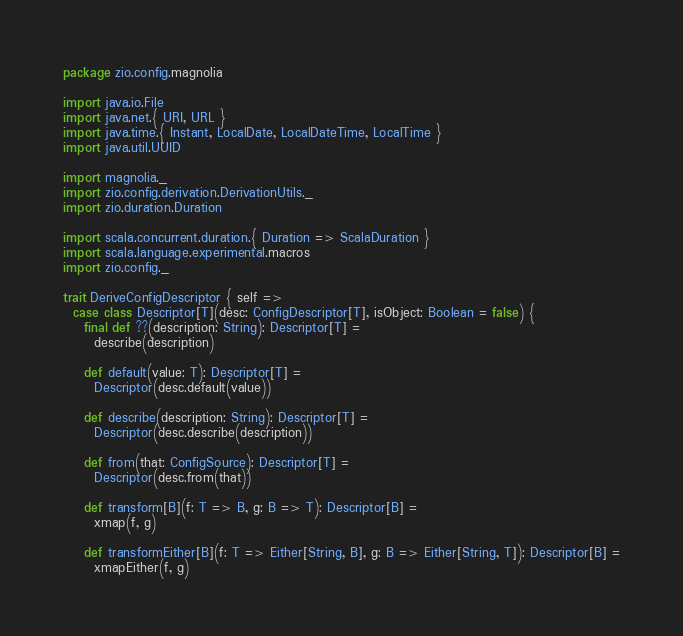Convert code to text. <code><loc_0><loc_0><loc_500><loc_500><_Scala_>package zio.config.magnolia

import java.io.File
import java.net.{ URI, URL }
import java.time.{ Instant, LocalDate, LocalDateTime, LocalTime }
import java.util.UUID

import magnolia._
import zio.config.derivation.DerivationUtils._
import zio.duration.Duration

import scala.concurrent.duration.{ Duration => ScalaDuration }
import scala.language.experimental.macros
import zio.config._

trait DeriveConfigDescriptor { self =>
  case class Descriptor[T](desc: ConfigDescriptor[T], isObject: Boolean = false) {
    final def ??(description: String): Descriptor[T] =
      describe(description)

    def default(value: T): Descriptor[T] =
      Descriptor(desc.default(value))

    def describe(description: String): Descriptor[T] =
      Descriptor(desc.describe(description))

    def from(that: ConfigSource): Descriptor[T] =
      Descriptor(desc.from(that))

    def transform[B](f: T => B, g: B => T): Descriptor[B] =
      xmap(f, g)

    def transformEither[B](f: T => Either[String, B], g: B => Either[String, T]): Descriptor[B] =
      xmapEither(f, g)
</code> 